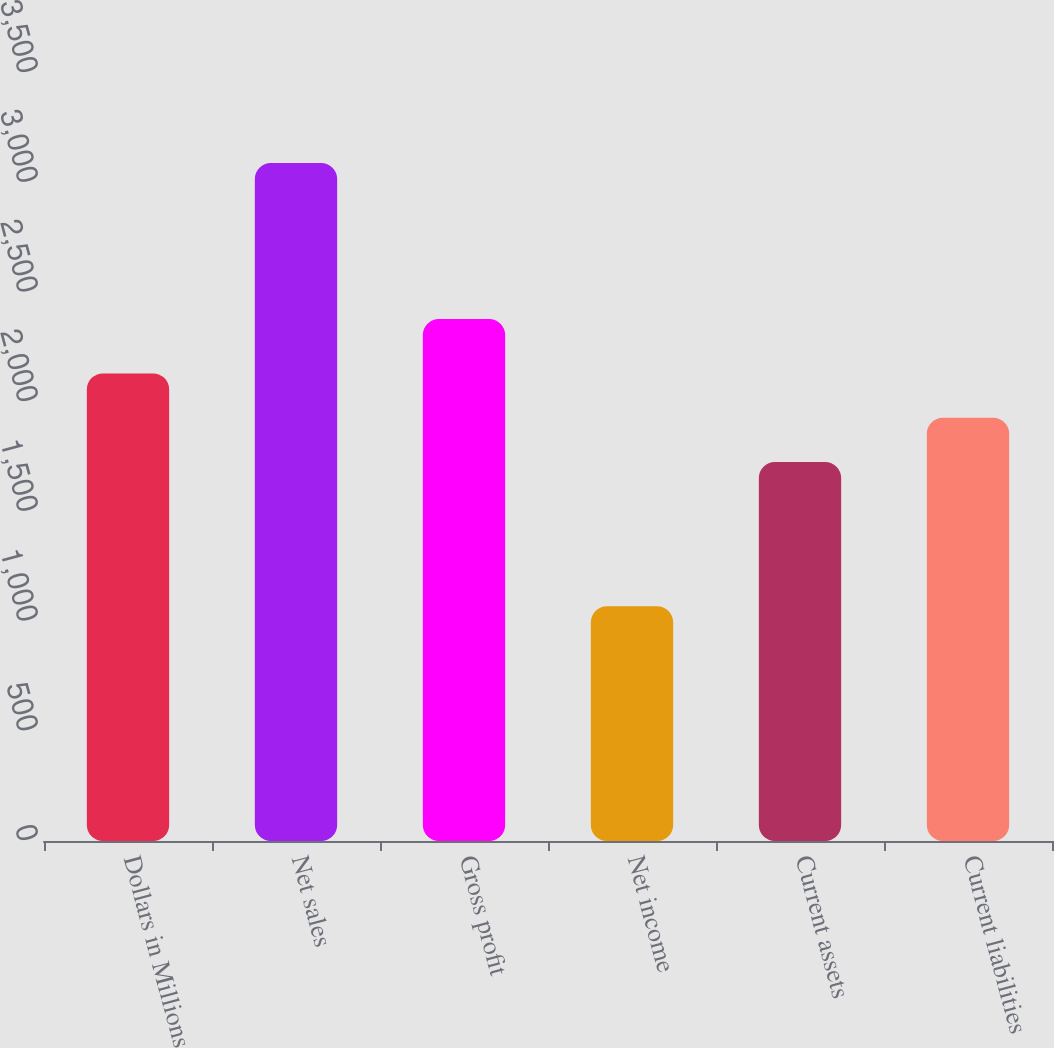Convert chart. <chart><loc_0><loc_0><loc_500><loc_500><bar_chart><fcel>Dollars in Millions<fcel>Net sales<fcel>Gross profit<fcel>Net income<fcel>Current assets<fcel>Current liabilities<nl><fcel>2131<fcel>3090<fcel>2379<fcel>1070<fcel>1727<fcel>1929<nl></chart> 